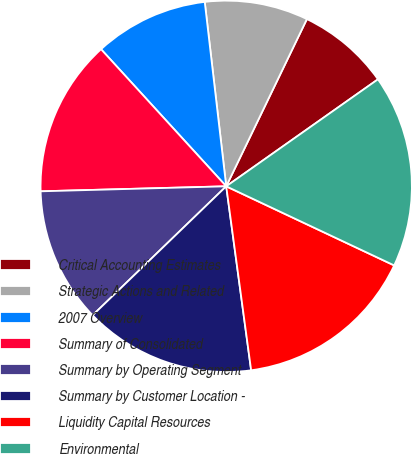Convert chart. <chart><loc_0><loc_0><loc_500><loc_500><pie_chart><fcel>Critical Accounting Estimates<fcel>Strategic Actions and Related<fcel>2007 Overview<fcel>Summary of Consolidated<fcel>Summary by Operating Segment<fcel>Summary by Customer Location -<fcel>Liquidity Capital Resources<fcel>Environmental<nl><fcel>8.07%<fcel>9.0%<fcel>9.93%<fcel>13.65%<fcel>11.79%<fcel>14.92%<fcel>15.85%<fcel>16.78%<nl></chart> 